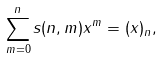<formula> <loc_0><loc_0><loc_500><loc_500>\sum _ { m = 0 } ^ { n } s ( n , m ) x ^ { m } = ( x ) _ { n } ,</formula> 